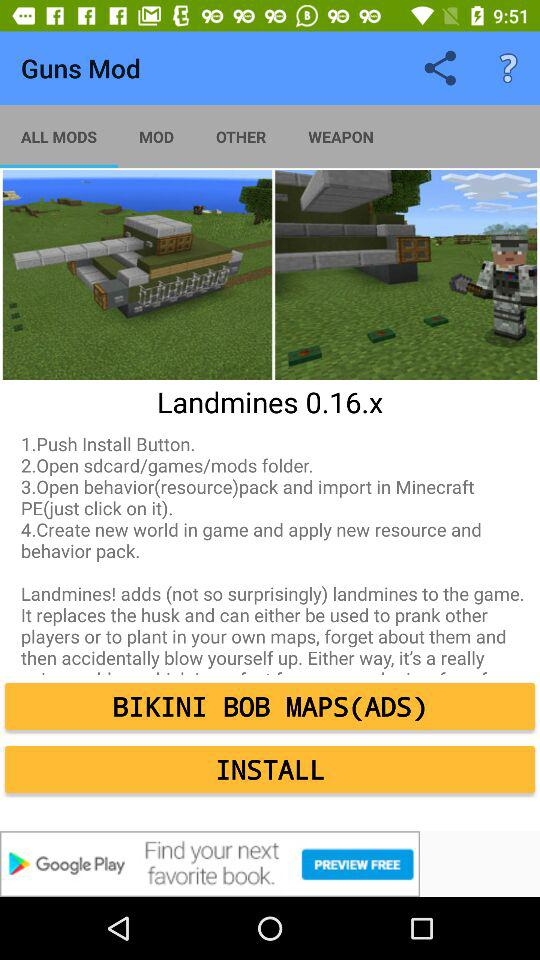How many weapons are available?
When the provided information is insufficient, respond with <no answer>. <no answer> 